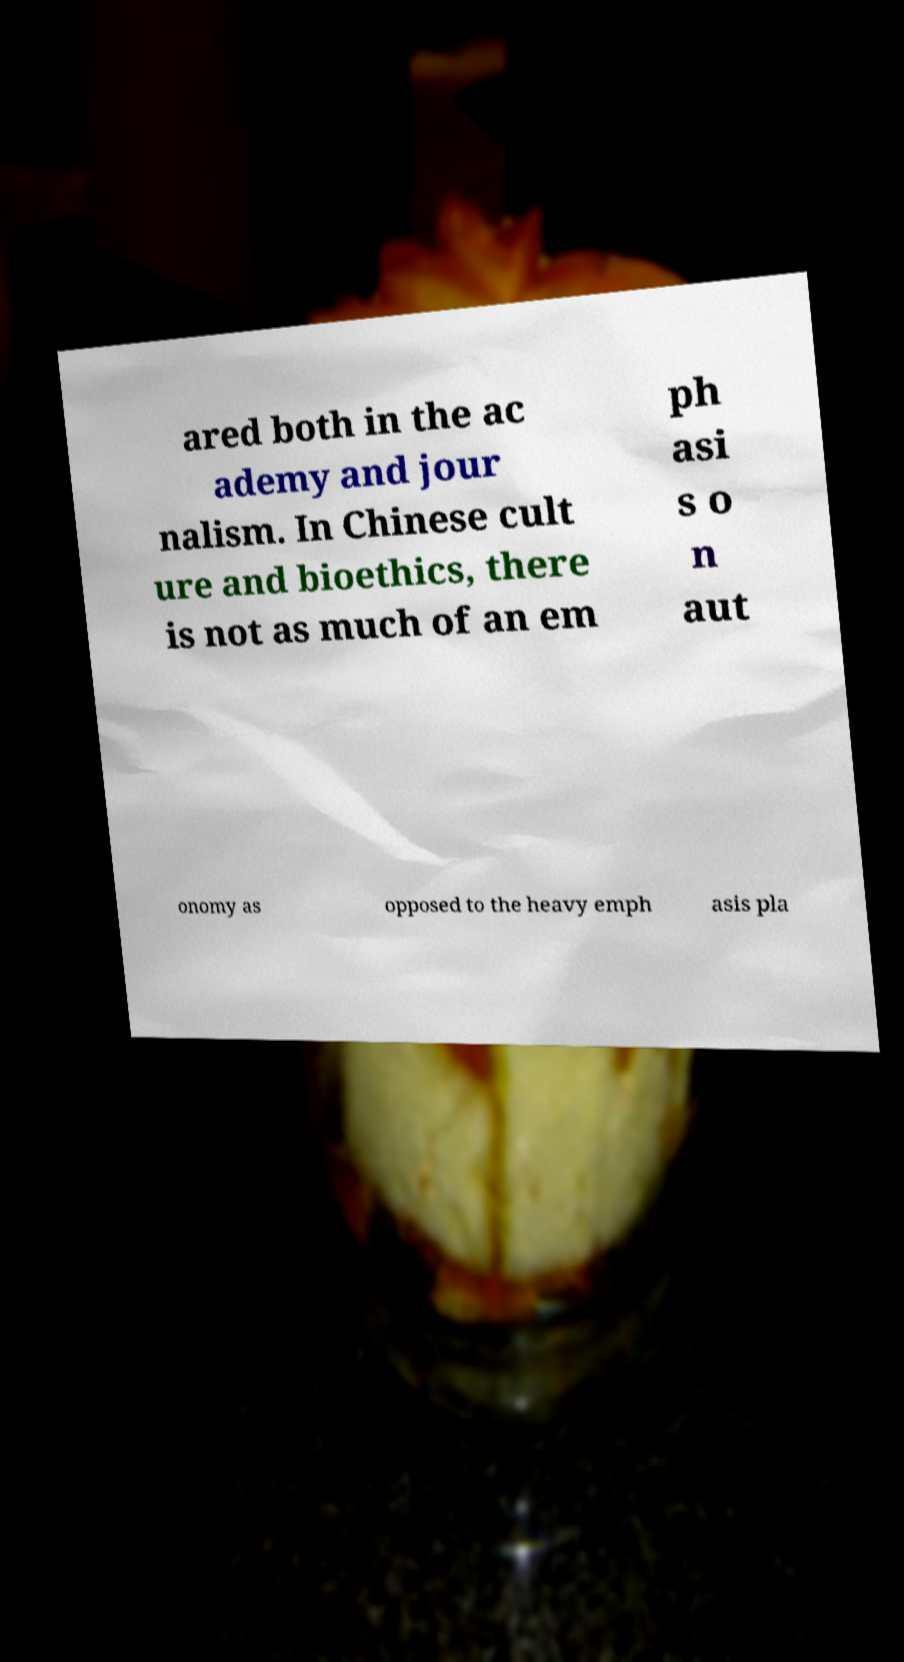I need the written content from this picture converted into text. Can you do that? ared both in the ac ademy and jour nalism. In Chinese cult ure and bioethics, there is not as much of an em ph asi s o n aut onomy as opposed to the heavy emph asis pla 